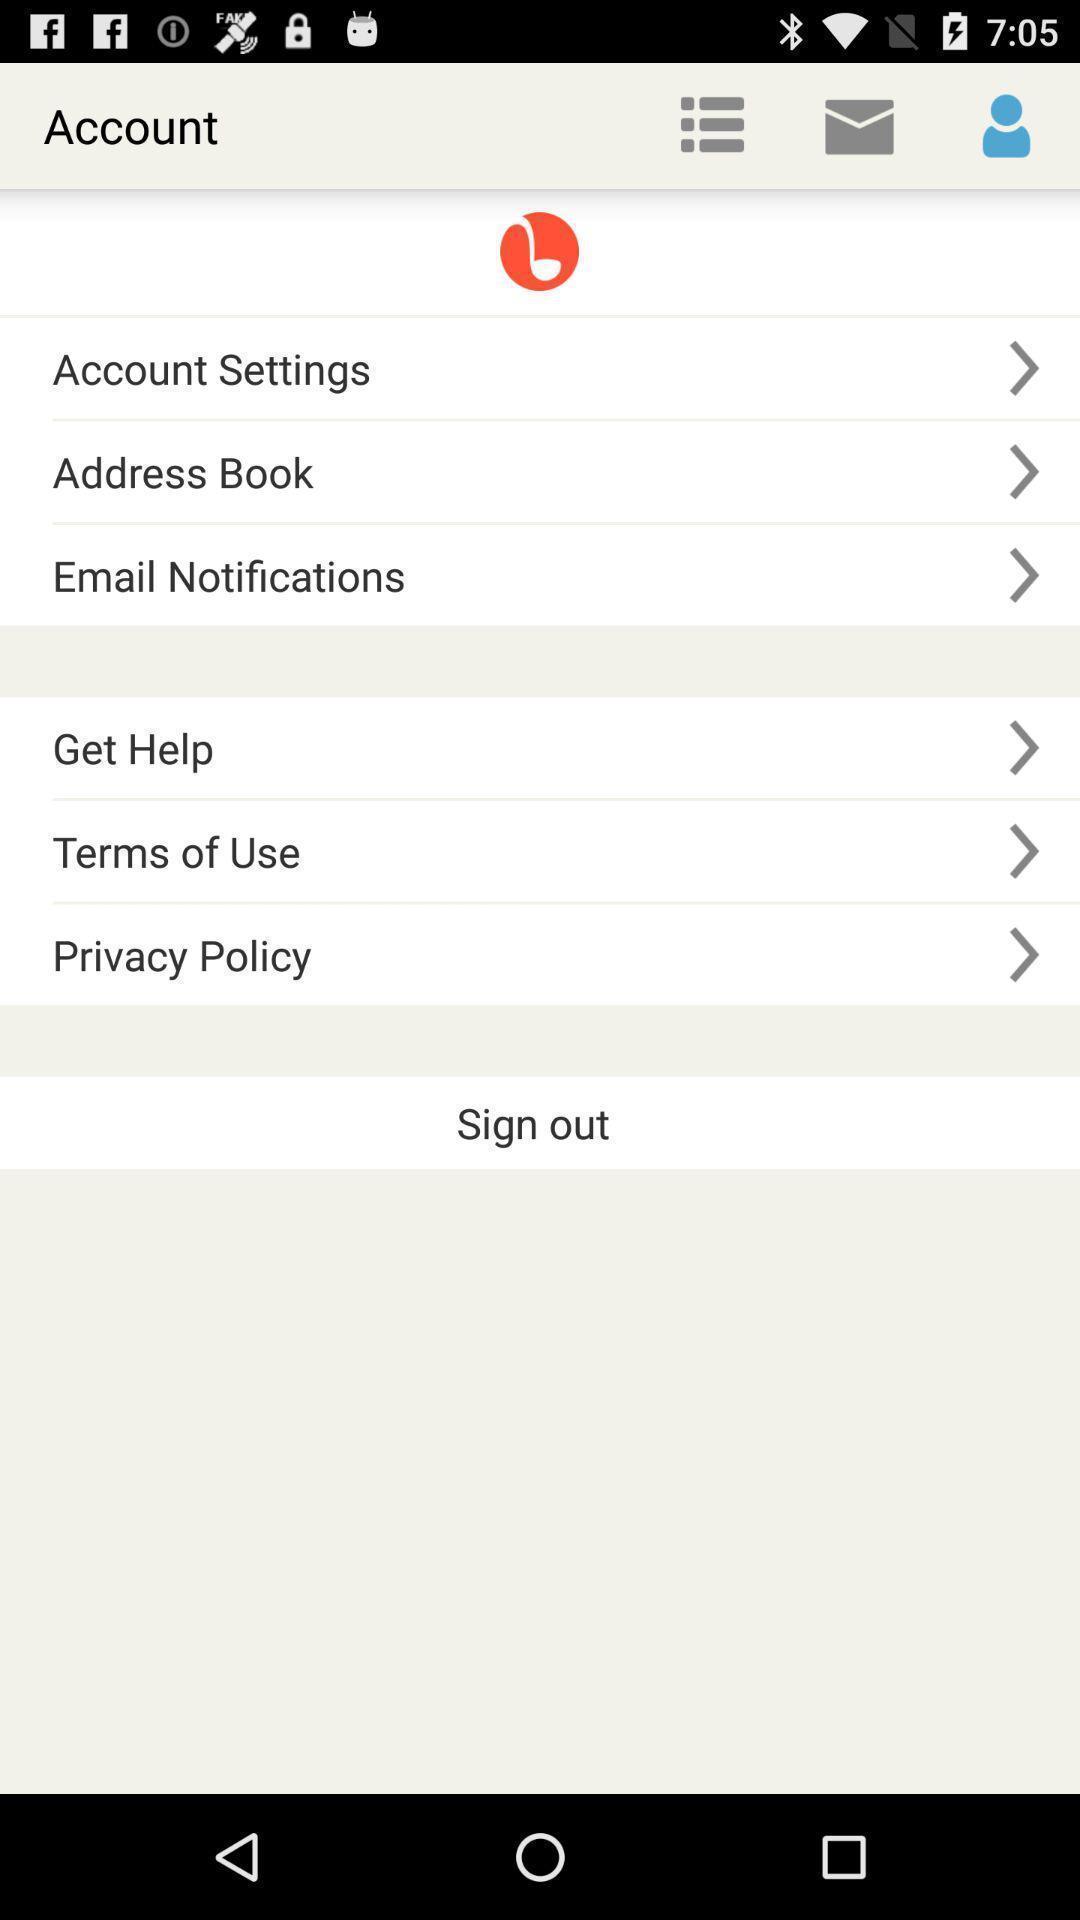Tell me about the visual elements in this screen capture. Screen shows account details of a social app. 